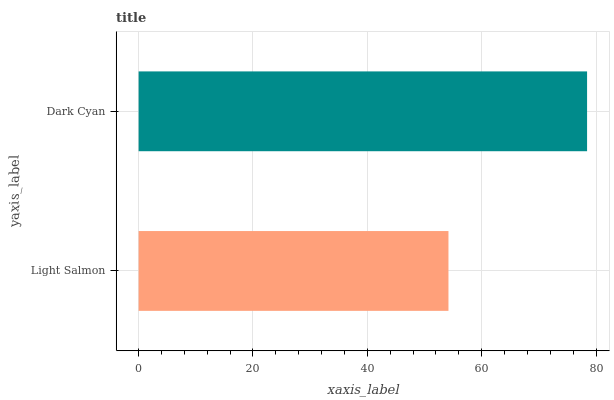Is Light Salmon the minimum?
Answer yes or no. Yes. Is Dark Cyan the maximum?
Answer yes or no. Yes. Is Dark Cyan the minimum?
Answer yes or no. No. Is Dark Cyan greater than Light Salmon?
Answer yes or no. Yes. Is Light Salmon less than Dark Cyan?
Answer yes or no. Yes. Is Light Salmon greater than Dark Cyan?
Answer yes or no. No. Is Dark Cyan less than Light Salmon?
Answer yes or no. No. Is Dark Cyan the high median?
Answer yes or no. Yes. Is Light Salmon the low median?
Answer yes or no. Yes. Is Light Salmon the high median?
Answer yes or no. No. Is Dark Cyan the low median?
Answer yes or no. No. 